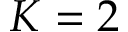<formula> <loc_0><loc_0><loc_500><loc_500>K = 2</formula> 